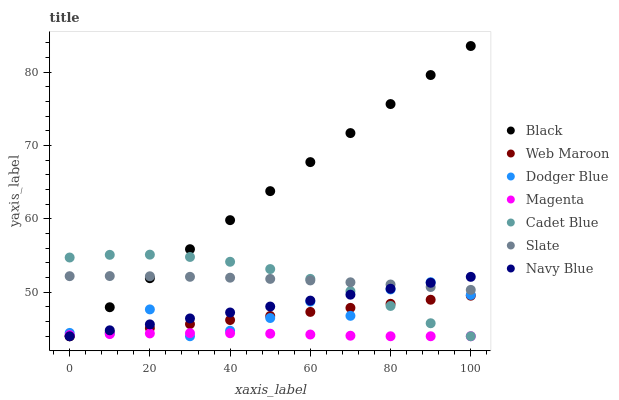Does Magenta have the minimum area under the curve?
Answer yes or no. Yes. Does Black have the maximum area under the curve?
Answer yes or no. Yes. Does Navy Blue have the minimum area under the curve?
Answer yes or no. No. Does Navy Blue have the maximum area under the curve?
Answer yes or no. No. Is Navy Blue the smoothest?
Answer yes or no. Yes. Is Dodger Blue the roughest?
Answer yes or no. Yes. Is Slate the smoothest?
Answer yes or no. No. Is Slate the roughest?
Answer yes or no. No. Does Cadet Blue have the lowest value?
Answer yes or no. Yes. Does Slate have the lowest value?
Answer yes or no. No. Does Black have the highest value?
Answer yes or no. Yes. Does Navy Blue have the highest value?
Answer yes or no. No. Is Web Maroon less than Slate?
Answer yes or no. Yes. Is Slate greater than Magenta?
Answer yes or no. Yes. Does Dodger Blue intersect Slate?
Answer yes or no. Yes. Is Dodger Blue less than Slate?
Answer yes or no. No. Is Dodger Blue greater than Slate?
Answer yes or no. No. Does Web Maroon intersect Slate?
Answer yes or no. No. 